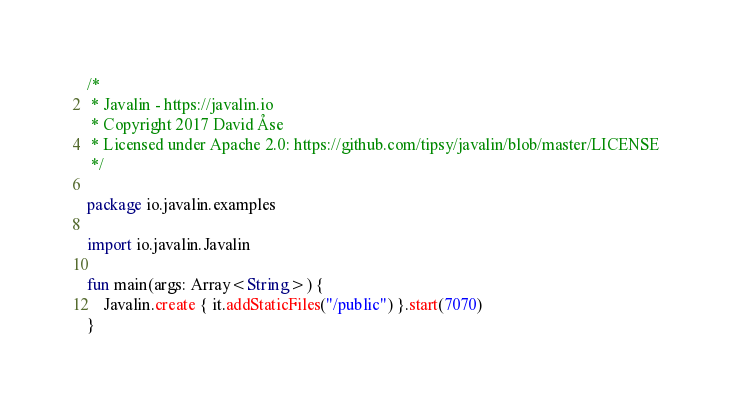Convert code to text. <code><loc_0><loc_0><loc_500><loc_500><_Kotlin_>/*
 * Javalin - https://javalin.io
 * Copyright 2017 David Åse
 * Licensed under Apache 2.0: https://github.com/tipsy/javalin/blob/master/LICENSE
 */

package io.javalin.examples

import io.javalin.Javalin

fun main(args: Array<String>) {
    Javalin.create { it.addStaticFiles("/public") }.start(7070)
}

</code> 